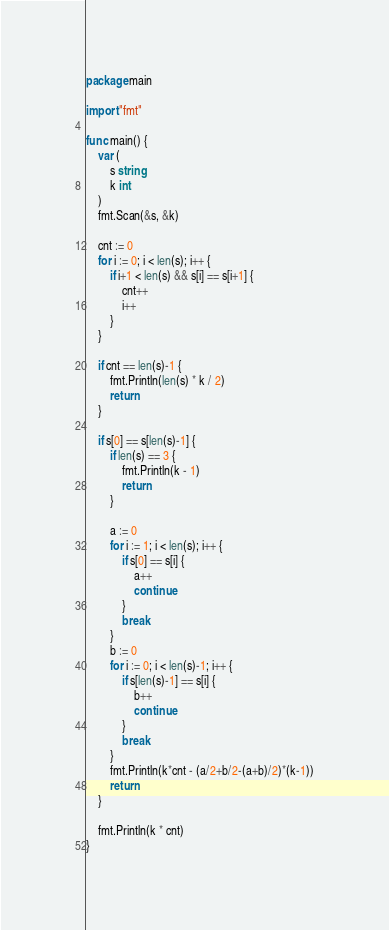<code> <loc_0><loc_0><loc_500><loc_500><_Go_>package main

import "fmt"

func main() {
	var (
		s string
		k int
	)
	fmt.Scan(&s, &k)

	cnt := 0
	for i := 0; i < len(s); i++ {
		if i+1 < len(s) && s[i] == s[i+1] {
			cnt++
			i++
		}
	}

	if cnt == len(s)-1 {
		fmt.Println(len(s) * k / 2)
		return
	}

	if s[0] == s[len(s)-1] {
		if len(s) == 3 {
			fmt.Println(k - 1)
			return
		}

		a := 0
		for i := 1; i < len(s); i++ {
			if s[0] == s[i] {
				a++
				continue
			}
			break
		}
		b := 0
		for i := 0; i < len(s)-1; i++ {
			if s[len(s)-1] == s[i] {
				b++
				continue
			}
			break
		}
		fmt.Println(k*cnt - (a/2+b/2-(a+b)/2)*(k-1))
		return
	}

	fmt.Println(k * cnt)
}
</code> 